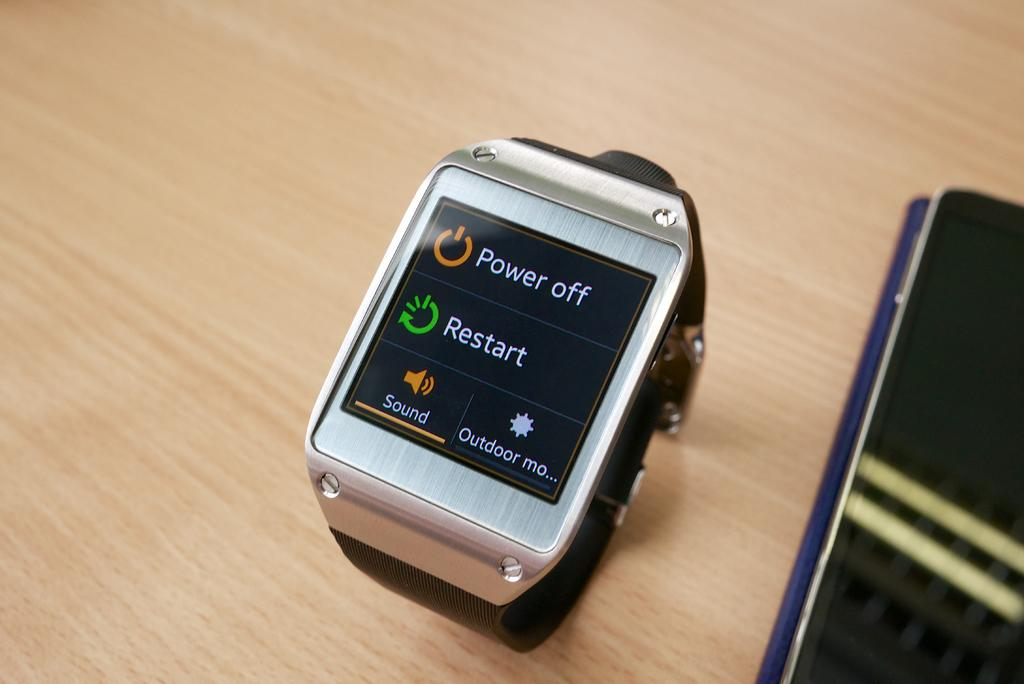<image>
Create a compact narrative representing the image presented. A smart watch is laying on a table with its power screen on. 